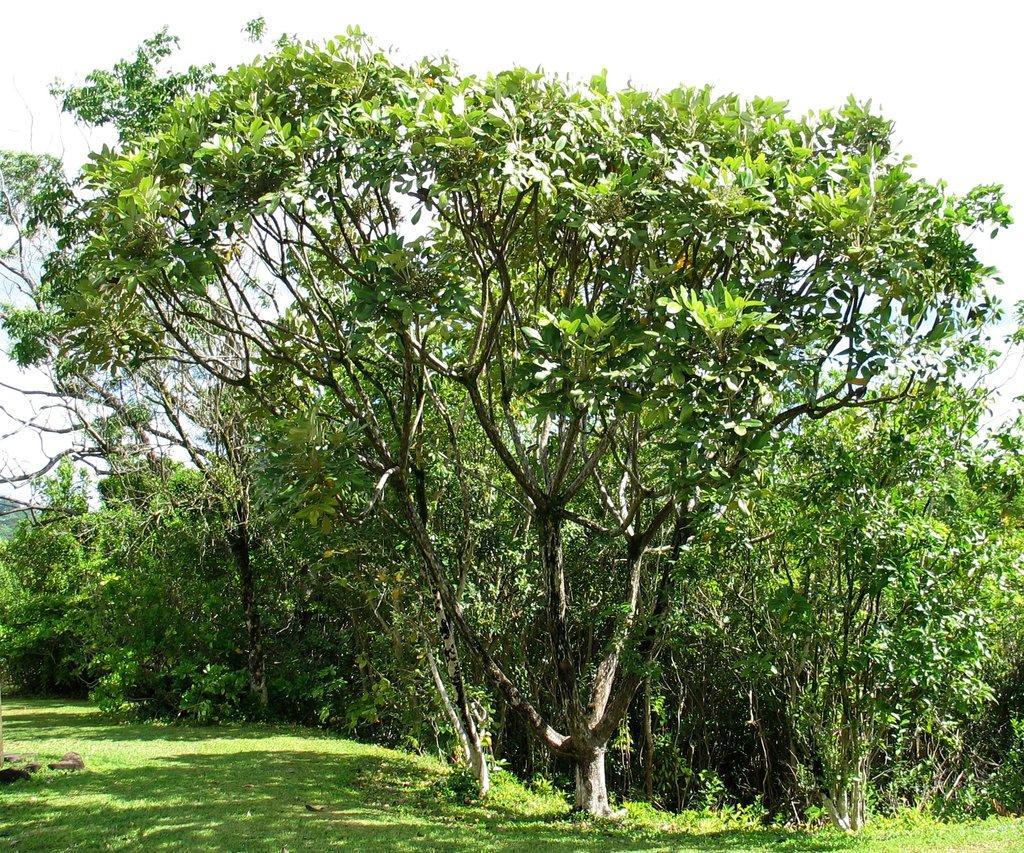In one or two sentences, can you explain what this image depicts? At the bottom of the image there is grass on the ground. And also there are many trees on the ground. In the background there is a sky. 